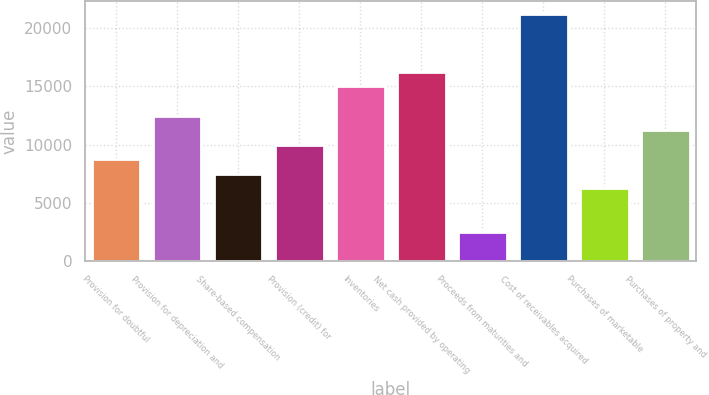Convert chart. <chart><loc_0><loc_0><loc_500><loc_500><bar_chart><fcel>Provision for doubtful<fcel>Provision for depreciation and<fcel>Share-based compensation<fcel>Provision (credit) for<fcel>Inventories<fcel>Net cash provided by operating<fcel>Proceeds from maturities and<fcel>Cost of receivables acquired<fcel>Purchases of marketable<fcel>Purchases of property and<nl><fcel>8753.08<fcel>12493.9<fcel>7506.14<fcel>10000<fcel>14987.8<fcel>16234.7<fcel>2518.38<fcel>21222.5<fcel>6259.2<fcel>11247<nl></chart> 